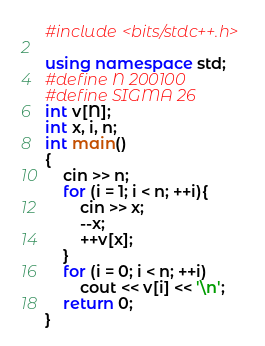<code> <loc_0><loc_0><loc_500><loc_500><_C++_>#include <bits/stdc++.h>

using namespace std;
#define N 200100
#define SIGMA 26
int v[N];
int x, i, n;
int main()
{
    cin >> n;
    for (i = 1; i < n; ++i){
        cin >> x;
        --x;
        ++v[x];
    }
    for (i = 0; i < n; ++i)
        cout << v[i] << '\n';
    return 0;
}
</code> 